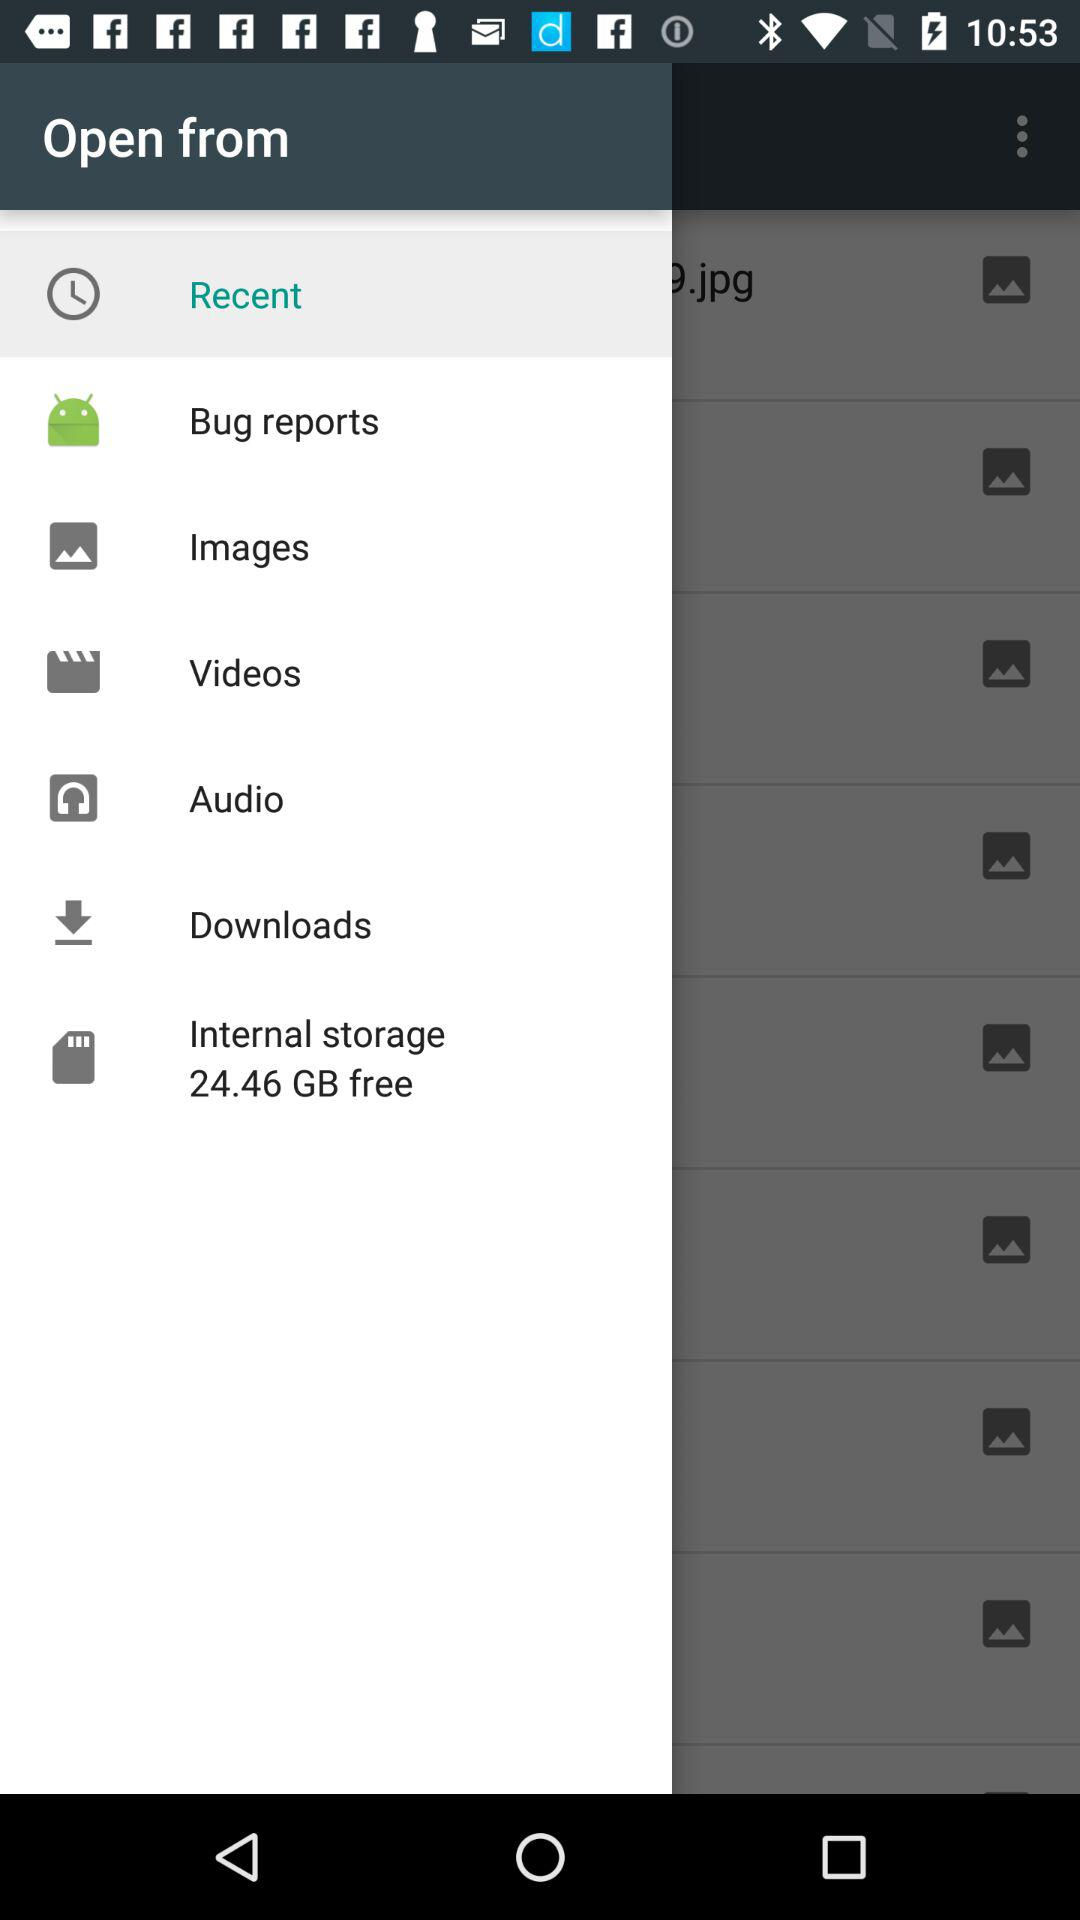What is the internal storage?
When the provided information is insufficient, respond with <no answer>. <no answer> 